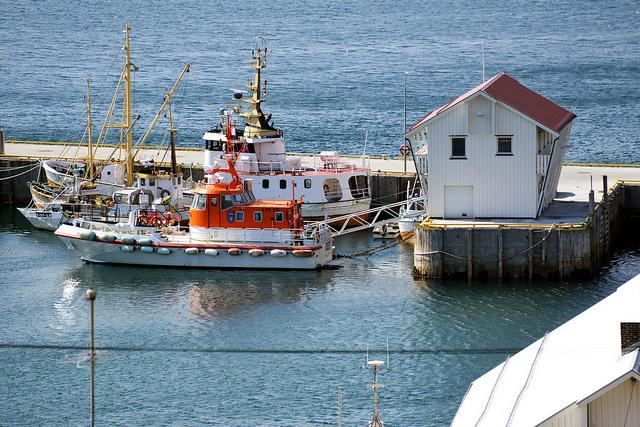What is above water?

Choices:
A) boat
B) swimmer
C) surfer
D) dolphin boat 